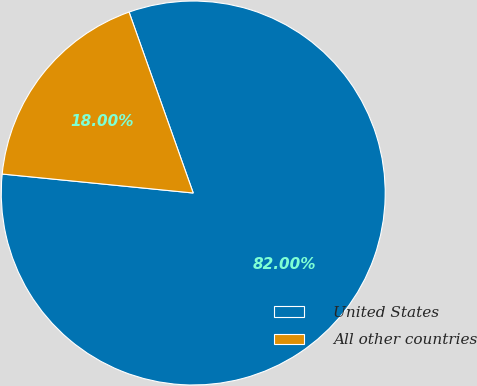Convert chart. <chart><loc_0><loc_0><loc_500><loc_500><pie_chart><fcel>United States<fcel>All other countries<nl><fcel>82.0%<fcel>18.0%<nl></chart> 